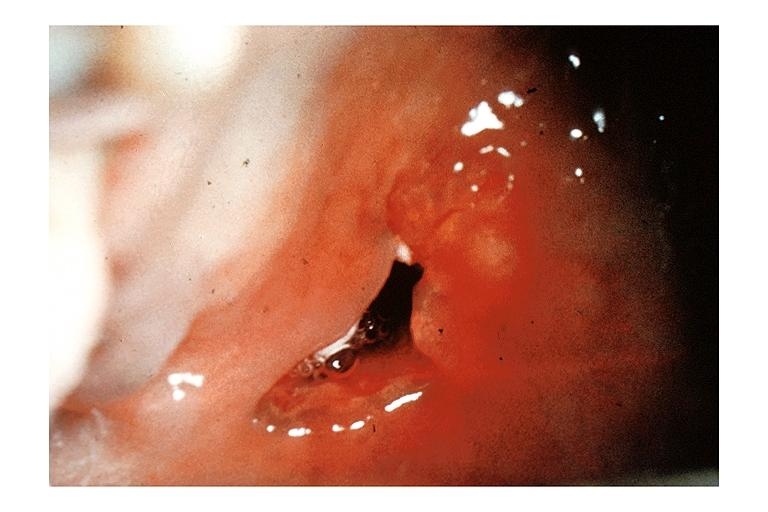where is this?
Answer the question using a single word or phrase. Oral 